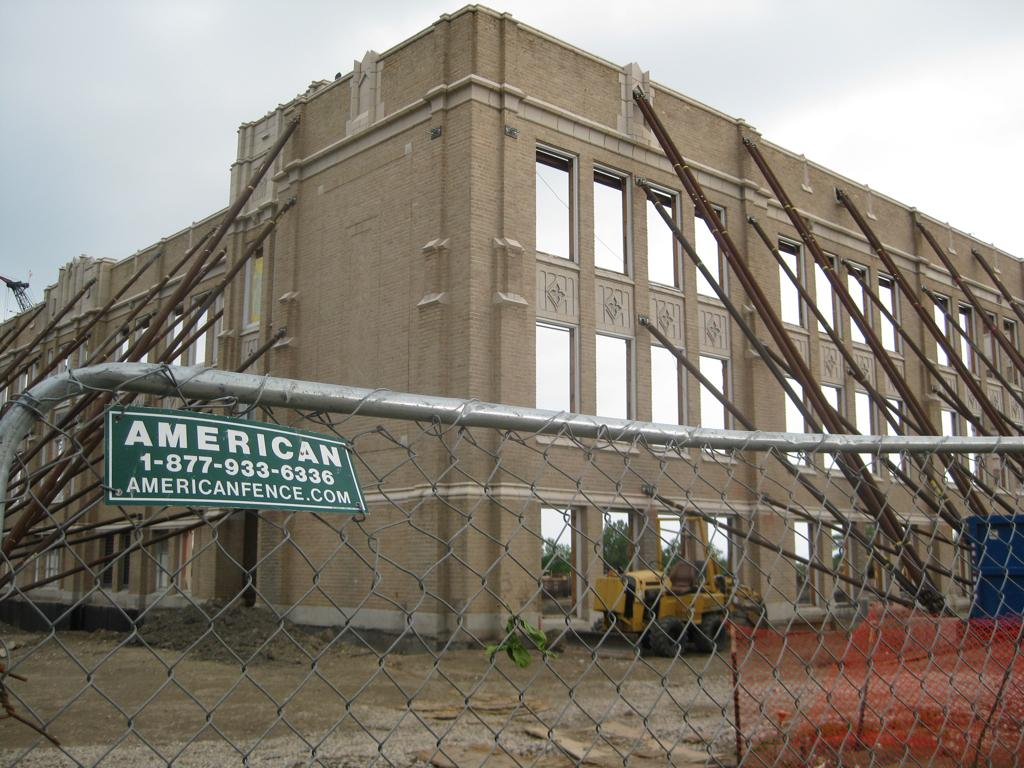What type of structure is present in the image? There is a building in the image. What other objects can be seen in the image? There are poles, meshes, a board, and an excavator in the image. What is the purpose of the poles and meshes? The purpose of the poles and meshes is not specified in the image, but they could be part of a construction site or fence. What is the excavator doing in the image? The image does not show the excavator in action, so it is unclear what it is doing. What can be seen in the background of the image? The sky is visible in the background of the image. How many dogs are playing with the excavator in the image? There are no dogs present in the image, and the excavator is not interacting with any animals. 